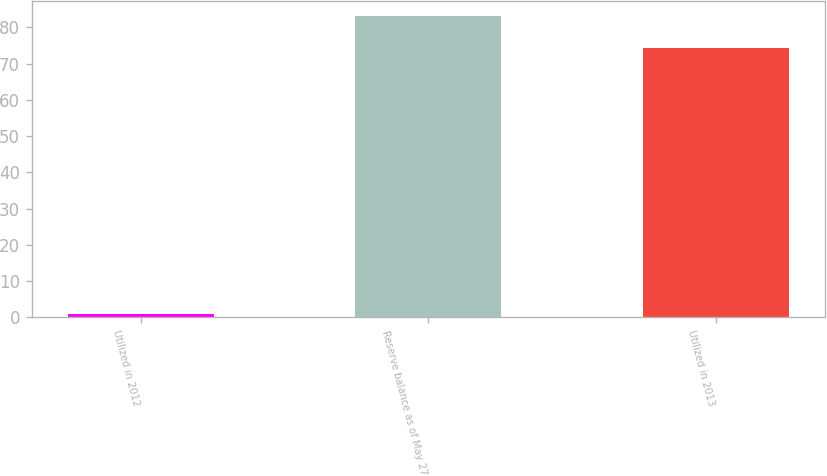Convert chart to OTSL. <chart><loc_0><loc_0><loc_500><loc_500><bar_chart><fcel>Utilized in 2012<fcel>Reserve balance as of May 27<fcel>Utilized in 2013<nl><fcel>1<fcel>83.1<fcel>74.2<nl></chart> 